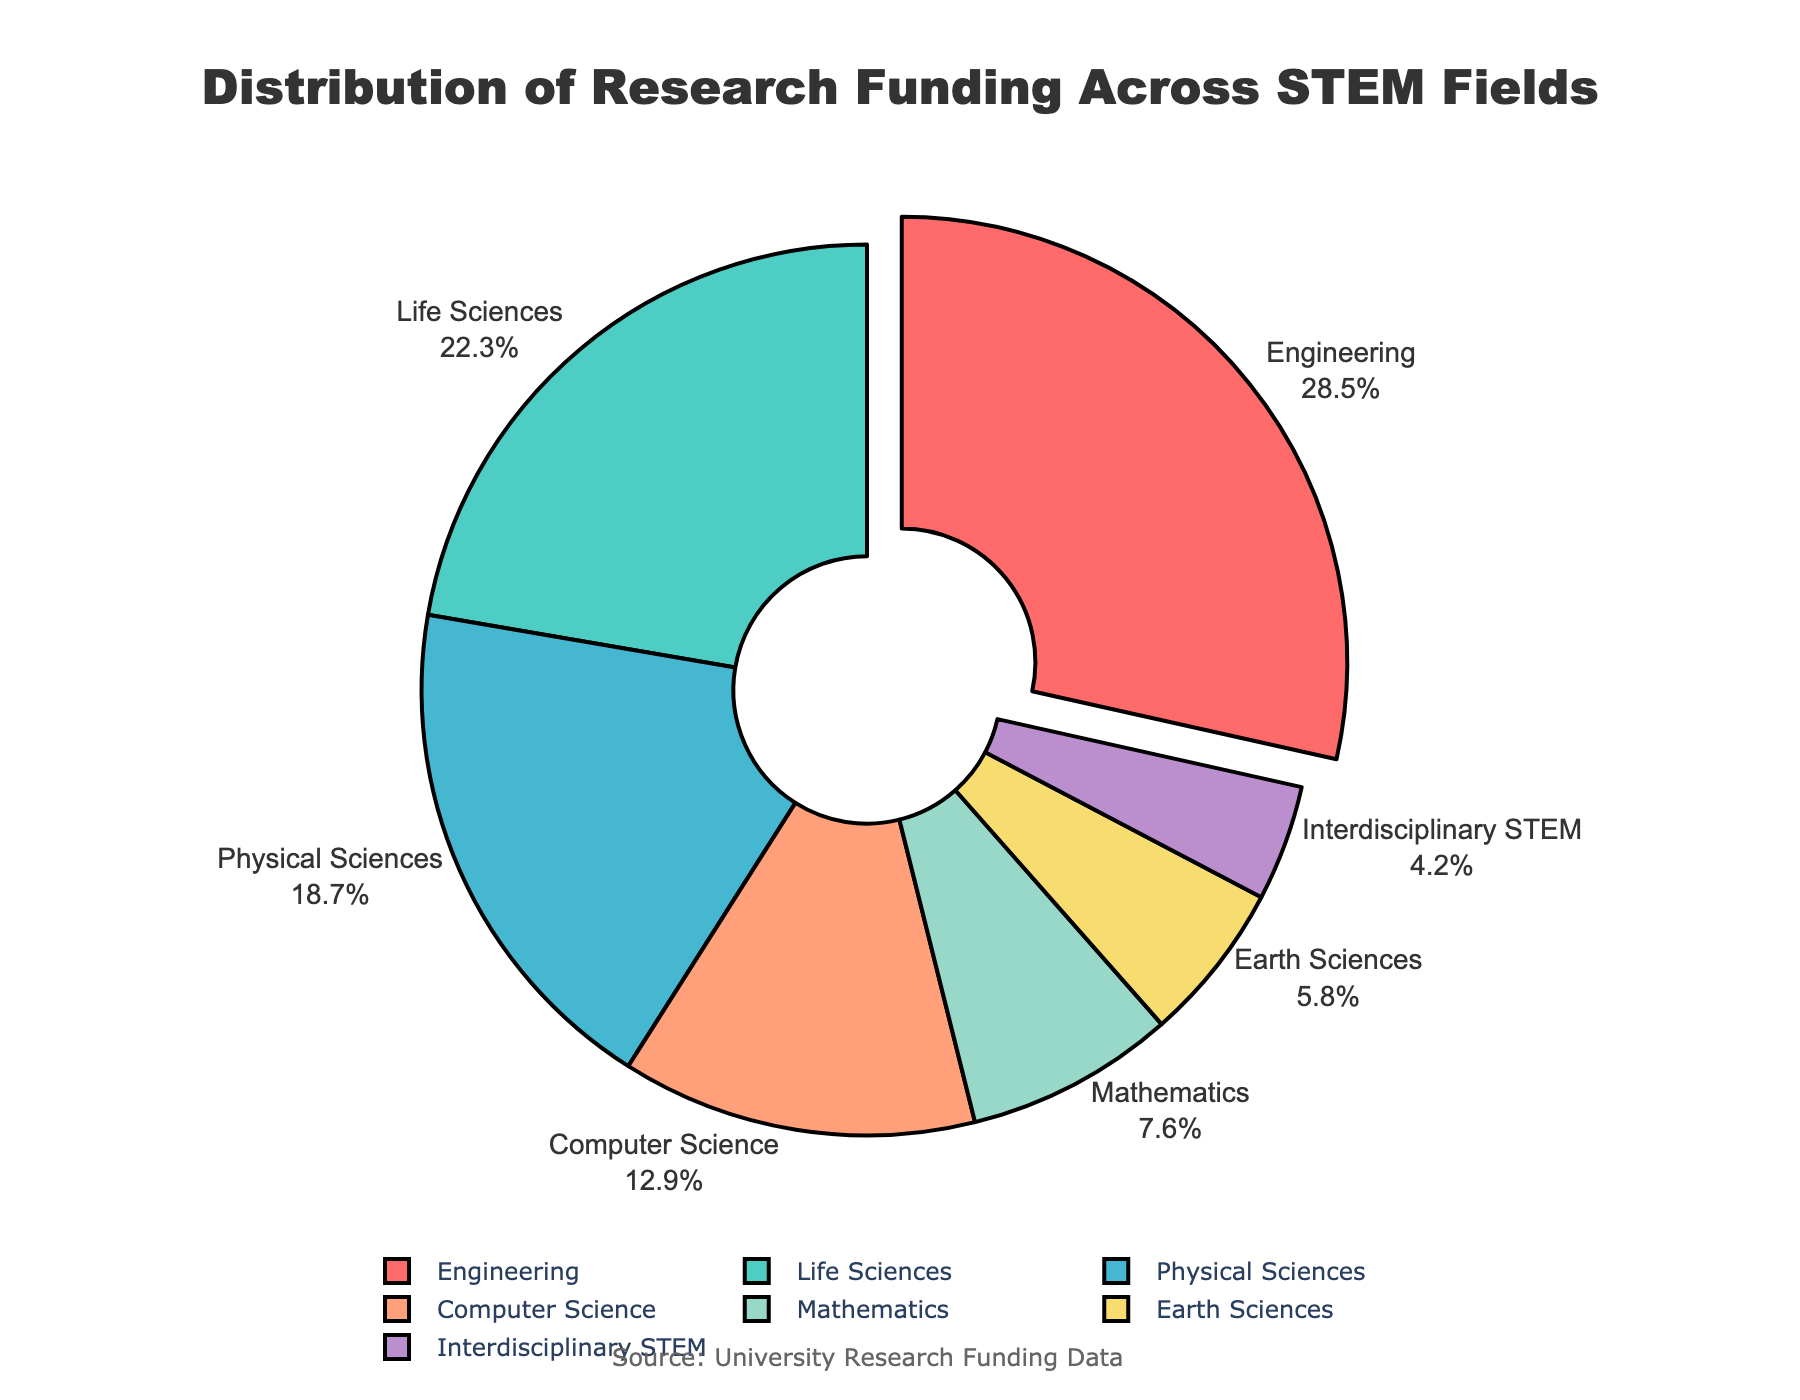What field receives the highest research funding? The pie chart shows that Engineering has the largest segment, indicating it has the highest research funding.
Answer: Engineering Which two fields, when combined, account for over 50% of the total funding? Adding the percentages of Engineering (28.5%) and Life Sciences (22.3%) yields 50.8%, which is over 50%.
Answer: Engineering and Life Sciences How much more funding does Computer Science receive compared to Earth Sciences? The funding for Computer Science is 12.9%, and for Earth Sciences, it's 5.8%. The difference is 12.9% - 5.8% = 7.1%.
Answer: 7.1% What's the average funding percentage of the three fields with the lowest funding? The three fields with the lowest percentages are Earth Sciences (5.8%), Interdisciplinary STEM (4.2%), and Mathematics (7.6%). The average funding percentage is (5.8 + 4.2 + 7.6) / 3 = 5.87%.
Answer: 5.87% Is the funding for Physical Sciences greater than the average funding percentage across all fields? The total funding percentage is 100%, divided across 7 fields. The average funding across all fields is 100% / 7 = 14.29%. The Physical Sciences receive 18.7%, which is greater.
Answer: Yes Which slice of the pie chart is pulled out? The chart has the Engineering slice slightly pulled out from the center.
Answer: Engineering How much more funding does Life Sciences receive than Mathematics? Life Sciences receive 22.3%, and Mathematics receives 7.6%. The difference is 22.3% - 7.6% = 14.7%.
Answer: 14.7% If Engineering's funding decreases by 5%, which field will become the one with the highest funding? Decreasing Engineering's funding by 5% means it would be 28.5% - 5% = 23.5%. It remains the highest because the next highest, Life Sciences, is only at 22.3%.
Answer: Engineering (still) What percentage of the funding is devoted to fields other than Engineering, Life Sciences, and Physical Sciences? The combined funding for Engineering, Life Sciences, and Physical Sciences is 28.5% + 22.3% + 18.7% = 69.5%. Therefore, the funding devoted to other fields is 100% - 69.5% = 30.5%.
Answer: 30.5% 